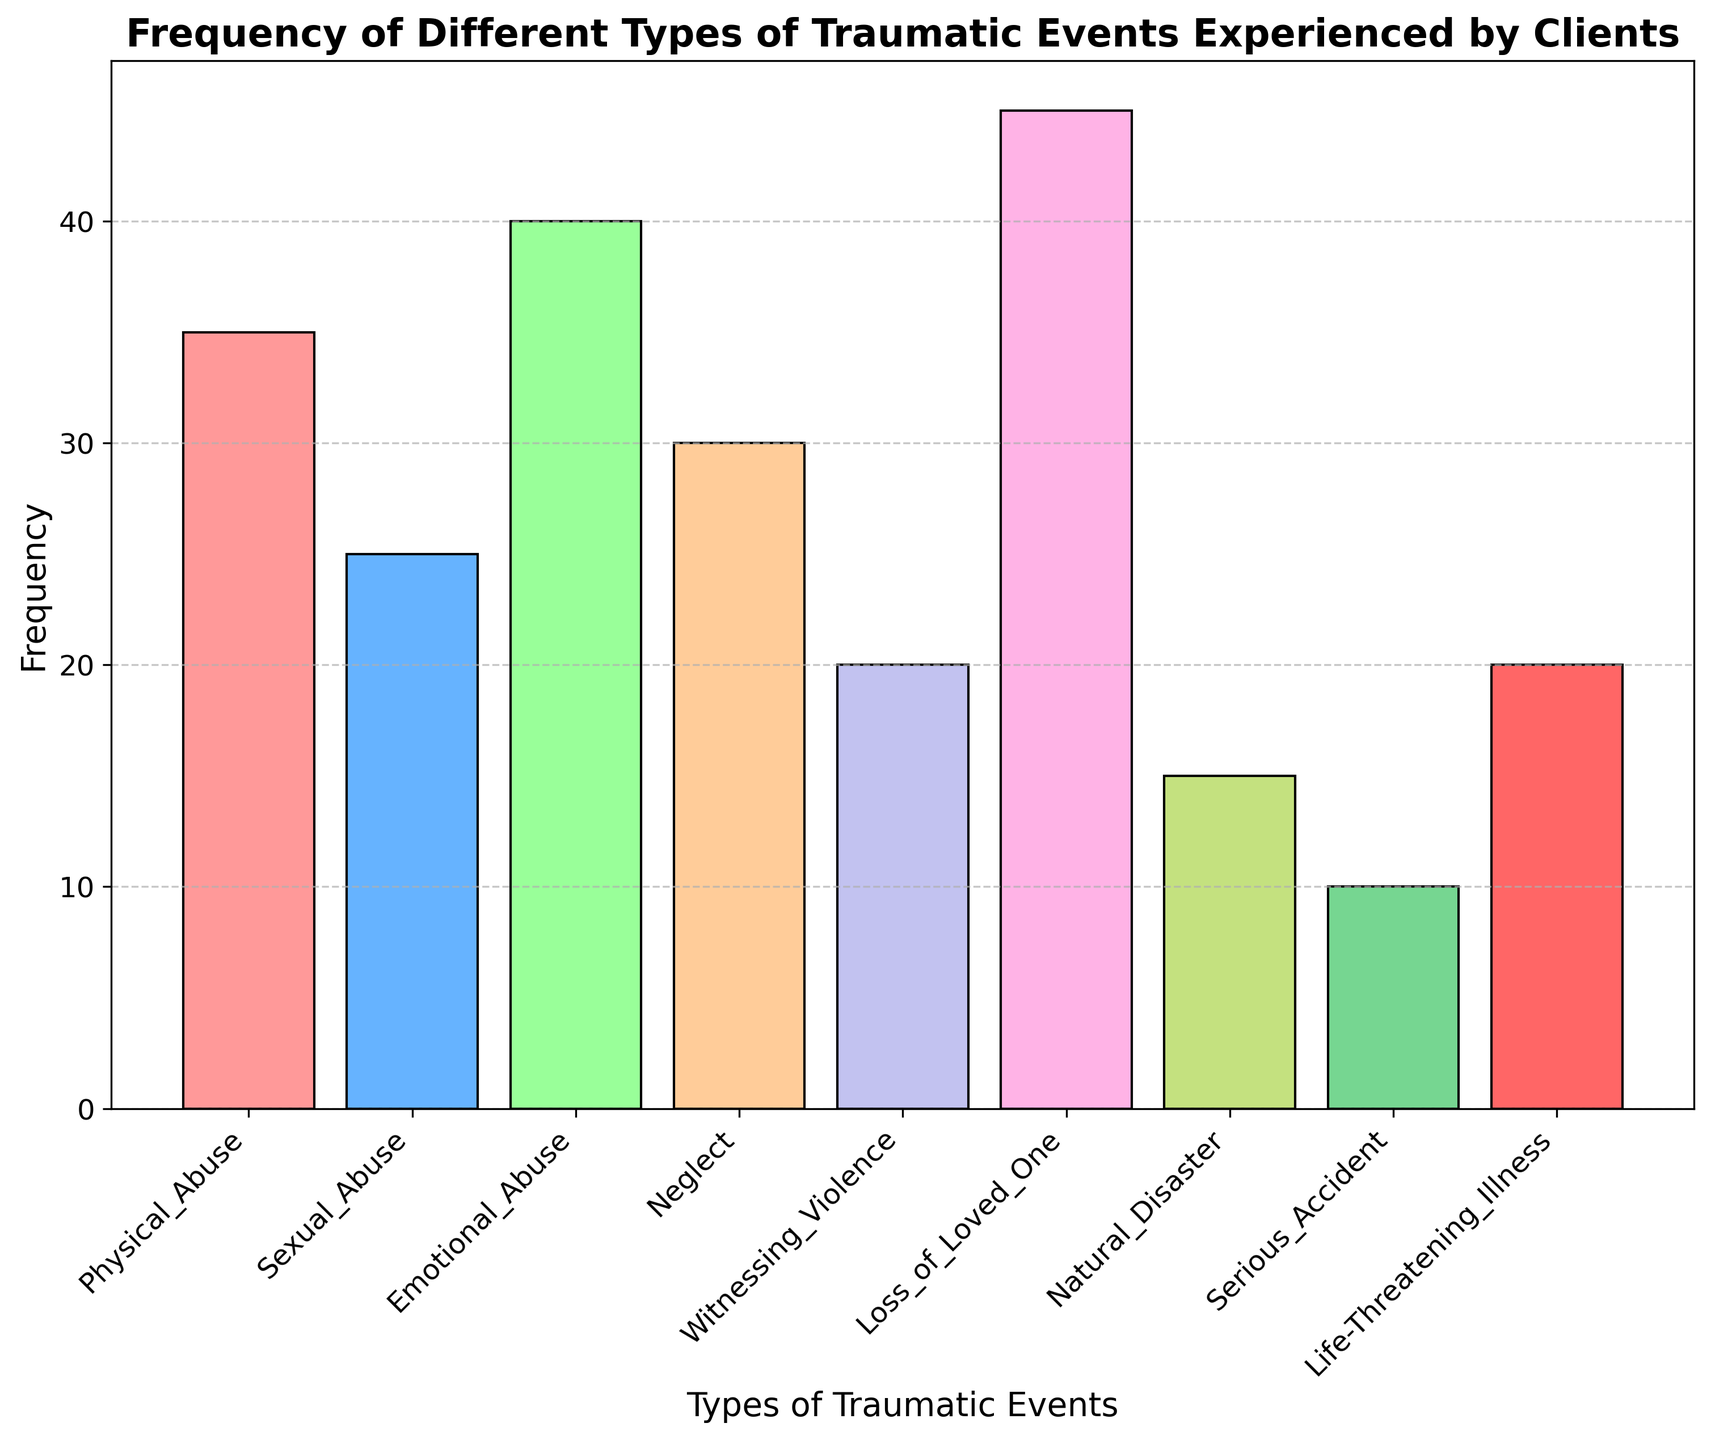What's the most frequently experienced traumatic event? To find the most frequently experienced event, look for the bar with the greatest height. The bar corresponding to the "Loss_of_Loved_One" has the highest frequency.
Answer: Loss of Loved One Which traumatic event has the least frequency? To identify the least frequent event, find the shortest bar in the histogram. The bar for "Serious_Accident" is the shortest.
Answer: Serious Accident How many more clients experienced Emotional Abuse compared to Sexual Abuse? Check the heights of the bars for "Emotional_Abuse" and "Sexual_Abuse". Emotional Abuse has a frequency of 40, and Sexual Abuse is at 25. The difference is 40 - 25.
Answer: 15 Which two types of traumatic events have the same frequency? Look for bars of equal height. Both "Witnessing_Violence" and "Life-Threatening_Illness" have the same height, at 20.
Answer: Witnessing Violence and Life-Threatening Illness What is the total number of clients who experienced either Neglect or Sexual Abuse? Add the frequencies of "Neglect" and "Sexual_Abuse". Neglect has 30 and Sexual Abuse has 25. Therefore, 30 + 25.
Answer: 55 What is the average frequency of all reported traumatic events? Sum the frequencies of all events and divide by the number of event types. Total frequency = 35 + 25 + 40 + 30 + 20 + 45 + 15 + 10 + 20 = 240. There are 9 event types. Average = 240/9.
Answer: 26.67 Are there more clients who experienced Natural Disasters or those who witnessed violence? Compare the frequencies of "Natural_Disaster" and "Witnessing_Violence". Natural Disaster has a frequency of 15, while Witnessing Violence has 20. 20 > 15, so more clients witnessed violence.
Answer: Witnessing Violence What is the combined frequency of clients who experienced Physical Abuse, Neglect, and Life-Threatening Illness? Add the frequencies of "Physical_Abuse" (35), "Neglect" (30), and "Life-Threatening_Illness" (20). 35 + 30 + 20.
Answer: 85 If a new traumatic event type with a frequency of 50 is added, what will be the new average frequency? Add the new frequency of 50 to the total frequency sum and divide by the new number of event types. Total frequency = 240 + 50 = 290. New number of event types = 10. New average = 290/10.
Answer: 29 